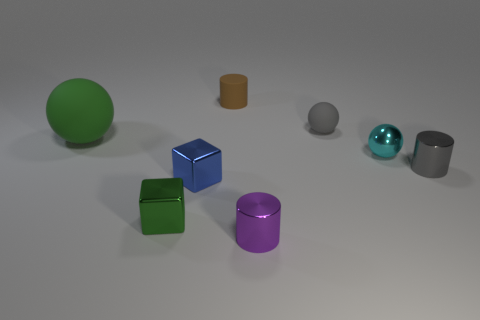There is a metal thing that is the same color as the big rubber ball; what shape is it?
Keep it short and to the point. Cube. What number of tiny cyan metal things have the same shape as the green matte thing?
Your response must be concise. 1. Are there an equal number of purple metallic things left of the small green block and purple metallic cylinders that are right of the green rubber thing?
Keep it short and to the point. No. Do the brown thing behind the small blue metal object and the thing on the left side of the green shiny block have the same shape?
Keep it short and to the point. No. Is there any other thing that is the same shape as the cyan object?
Give a very brief answer. Yes. What is the shape of the tiny gray thing that is made of the same material as the brown thing?
Your answer should be very brief. Sphere. Is the number of small gray metallic objects that are behind the tiny brown matte cylinder the same as the number of green spheres?
Offer a very short reply. No. Is the material of the small cylinder that is behind the big matte sphere the same as the green object that is in front of the green ball?
Give a very brief answer. No. What is the shape of the small purple object that is in front of the cylinder behind the gray shiny cylinder?
Your response must be concise. Cylinder. The tiny cylinder that is made of the same material as the large object is what color?
Make the answer very short. Brown. 